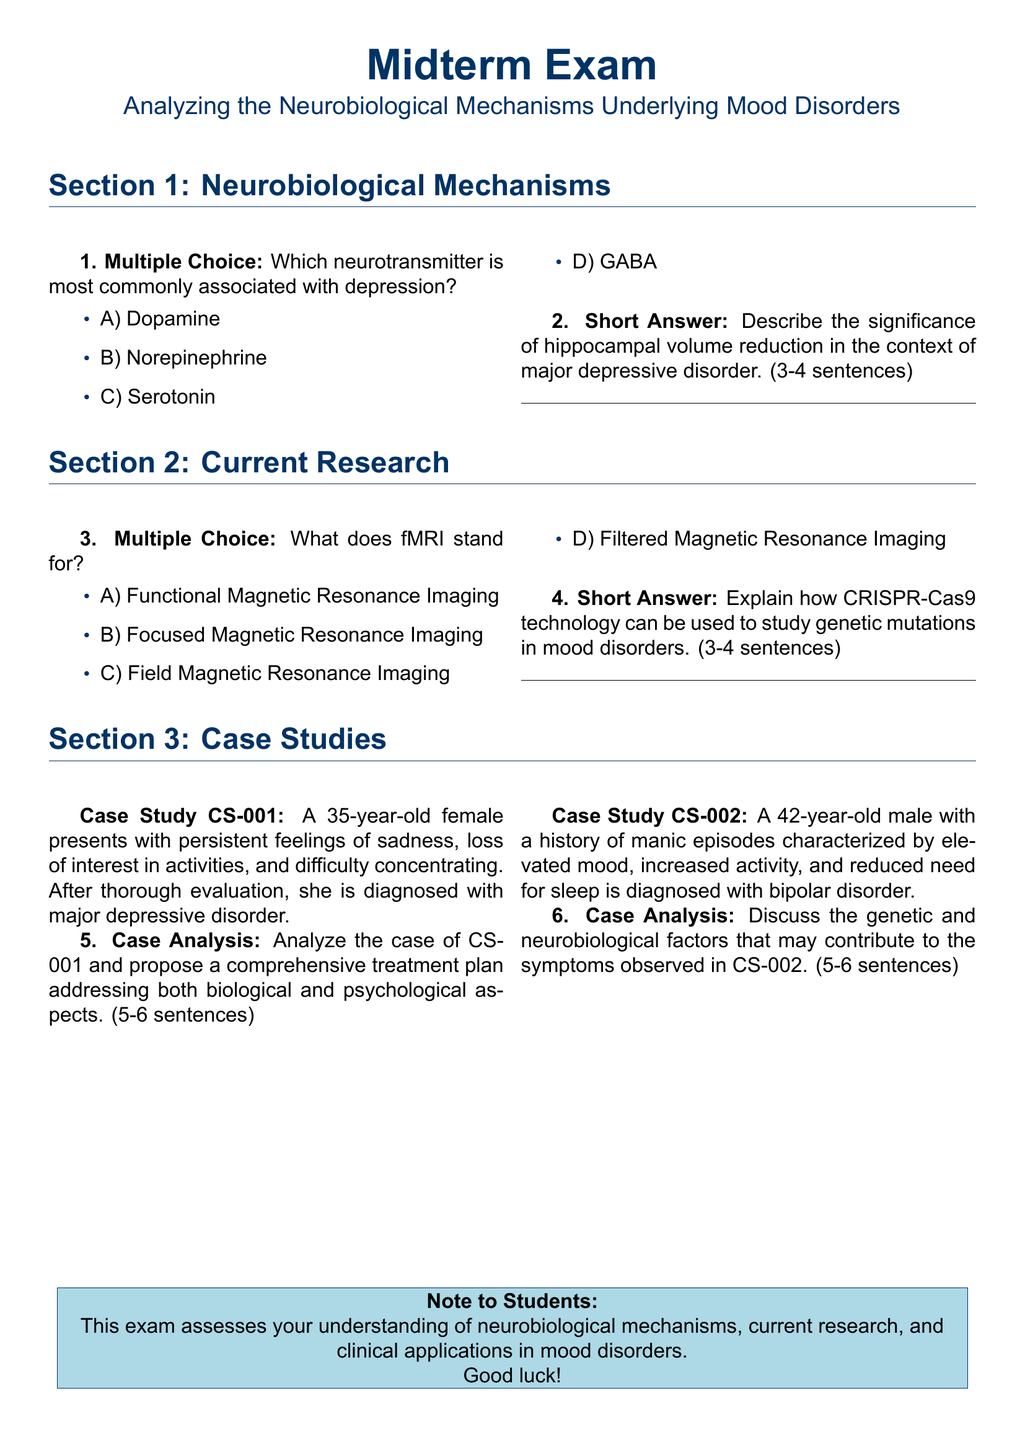What is the title of the midterm exam? The title is a prominent feature of the document, presented at the top.
Answer: A midterm exam What is the name of the neurotransmitter most commonly associated with depression? This information is found in the multiple-choice section of the document.
Answer: Serotonin What does fMRI stand for? The acronym is defined in one of the multiple-choice questions in the document.
Answer: Functional Magnetic Resonance Imaging What is the case study number of the first case study? The case study notation is provided in the case studies section for identification.
Answer: CS-001 What is the diagnosis for the male in case study CS-002? This information is stated at the end of the description of the male's history and symptoms.
Answer: Bipolar disorder How many sentences should the case analysis responses contain? The required length for responses is specified in each case study analysis prompt.
Answer: 5-6 sentences What type of technology is mentioned for studying genetic mutations in mood disorders? This technology is referenced in the short answer section of current research.
Answer: CRISPR-Cas9 What is the age of the female patient in case study CS-001? The age is included in the case study description.
Answer: 35 What psychological condition does the first case study present? This condition is diagnosed after an evaluation of the patient's symptoms.
Answer: Major depressive disorder 